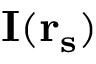Convert formula to latex. <formula><loc_0><loc_0><loc_500><loc_500>I ( r _ { s } )</formula> 